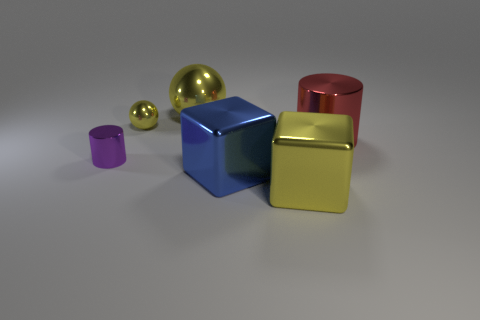Does the large object behind the big red metal cylinder have the same material as the large cube that is left of the yellow metallic cube?
Your response must be concise. Yes. Is the number of big red cylinders in front of the purple object less than the number of large yellow blocks?
Provide a succinct answer. Yes. What color is the other metallic object that is the same shape as the large blue metallic object?
Keep it short and to the point. Yellow. Do the yellow metal object that is in front of the purple metallic thing and the blue metal block have the same size?
Give a very brief answer. Yes. What is the size of the yellow shiny ball on the left side of the large shiny thing left of the blue object?
Your response must be concise. Small. Is the material of the tiny sphere the same as the yellow thing that is in front of the small purple shiny object?
Provide a short and direct response. Yes. Is the number of yellow shiny spheres to the left of the tiny purple cylinder less than the number of big red things to the left of the blue cube?
Your answer should be compact. No. What is the color of the tiny cylinder that is made of the same material as the tiny ball?
Your answer should be very brief. Purple. Is there a large red metallic cylinder on the left side of the tiny object that is behind the purple shiny thing?
Ensure brevity in your answer.  No. There is a metal sphere that is the same size as the purple object; what is its color?
Your answer should be very brief. Yellow. 